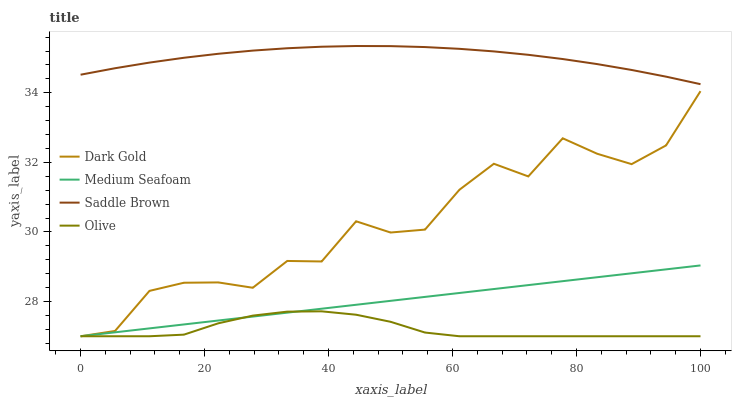Does Olive have the minimum area under the curve?
Answer yes or no. Yes. Does Saddle Brown have the maximum area under the curve?
Answer yes or no. Yes. Does Medium Seafoam have the minimum area under the curve?
Answer yes or no. No. Does Medium Seafoam have the maximum area under the curve?
Answer yes or no. No. Is Medium Seafoam the smoothest?
Answer yes or no. Yes. Is Dark Gold the roughest?
Answer yes or no. Yes. Is Olive the smoothest?
Answer yes or no. No. Is Olive the roughest?
Answer yes or no. No. Does Olive have the lowest value?
Answer yes or no. Yes. Does Saddle Brown have the highest value?
Answer yes or no. Yes. Does Medium Seafoam have the highest value?
Answer yes or no. No. Is Olive less than Saddle Brown?
Answer yes or no. Yes. Is Saddle Brown greater than Olive?
Answer yes or no. Yes. Does Dark Gold intersect Olive?
Answer yes or no. Yes. Is Dark Gold less than Olive?
Answer yes or no. No. Is Dark Gold greater than Olive?
Answer yes or no. No. Does Olive intersect Saddle Brown?
Answer yes or no. No. 